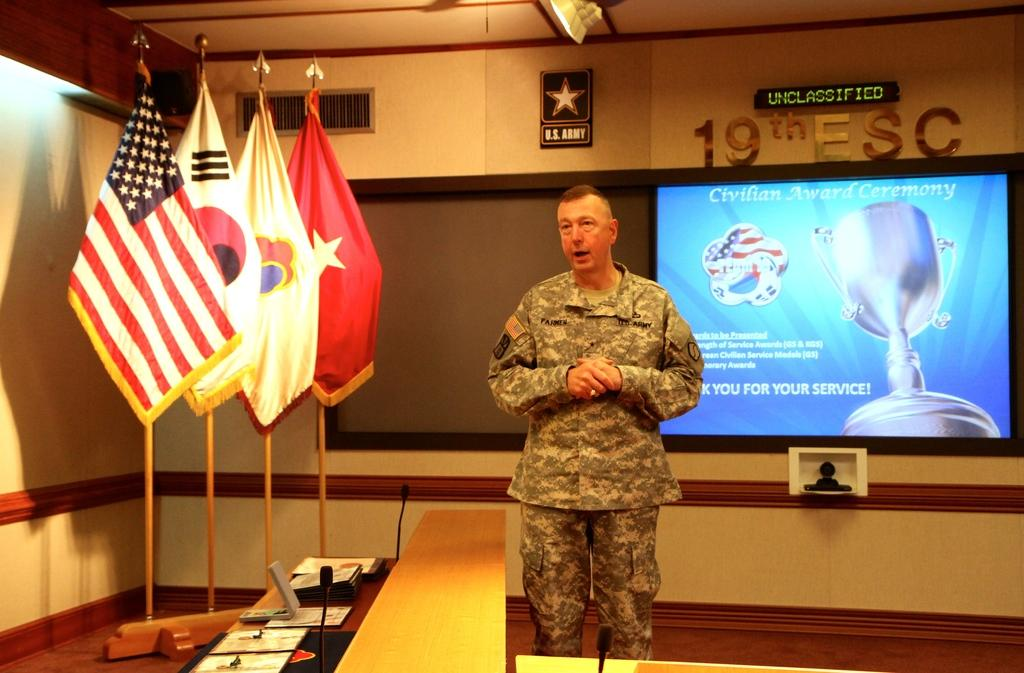Who is the main subject in the image? There is a man in the middle of the image. What object is on the table in the image? There is a laptop on the table. What else is on the table besides the laptop? Papers and microphones are visible on the table. What can be seen in the background of the image? There are flags, a wall, a screen, and light in the background of the image. What type of boat is visible in the image? There is no boat present in the image. What is the nature of the argument taking place in the image? There is no argument present in the image; it features a man, a laptop, papers, microphones, flags, a wall, a screen, and light. 